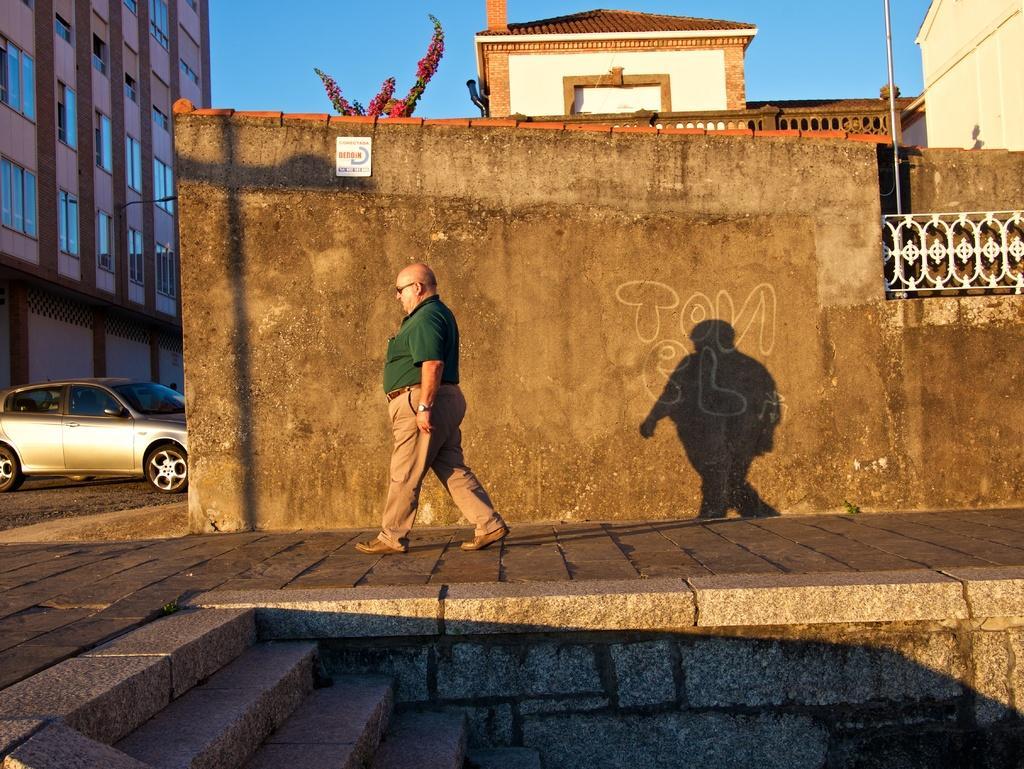Could you give a brief overview of what you see in this image? In this image I can see a person walking on road, in front of the wall , on the wall I can see text and fence and at the bottom I can see a staircase and on the left side I can see a car and building and at the top I can see the sky and building and pole and plant contain flower. 